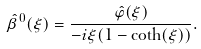Convert formula to latex. <formula><loc_0><loc_0><loc_500><loc_500>\hat { \beta } ^ { 0 } ( \xi ) = \frac { \hat { \varphi } ( \xi ) } { - i \xi ( 1 - \coth ( \xi ) ) } .</formula> 